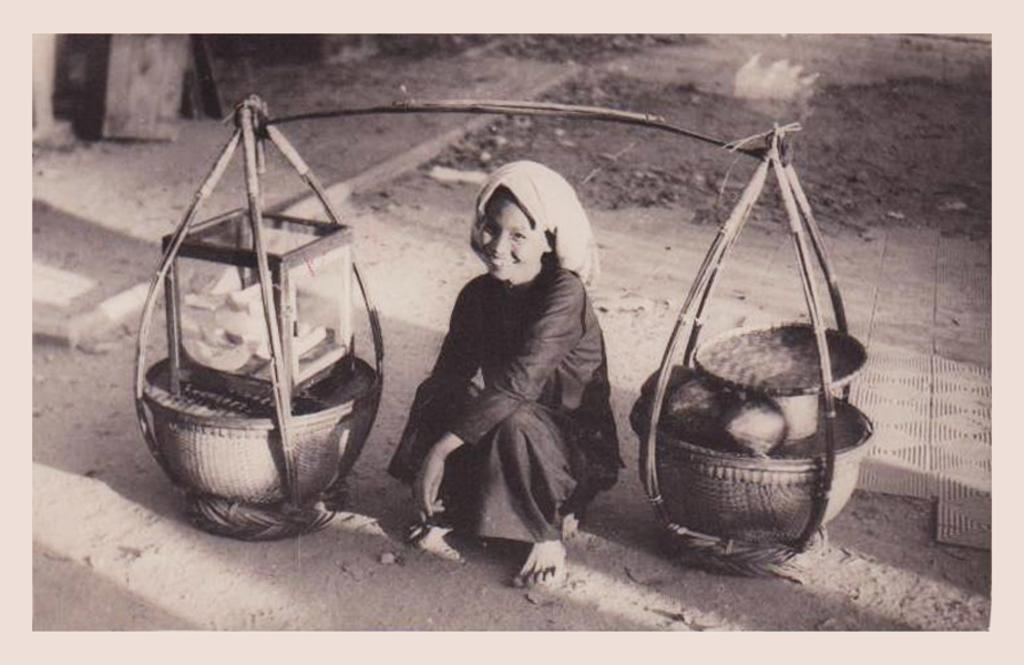What is the person in the image doing? There is a person sitting in the image. What object can be seen in the image that is used for carrying things? There is a carrying pole in the image. What is attached to the carrying pole? There are objects on the carrying pole. What is the color scheme of the image? The image is black and white. How many clocks are hanging from the hook in the image? There is no hook or clocks present in the image. What type of arch can be seen in the background of the image? There is no arch visible in the image; it is a black and white image with a person sitting and a carrying pole with objects on it. 